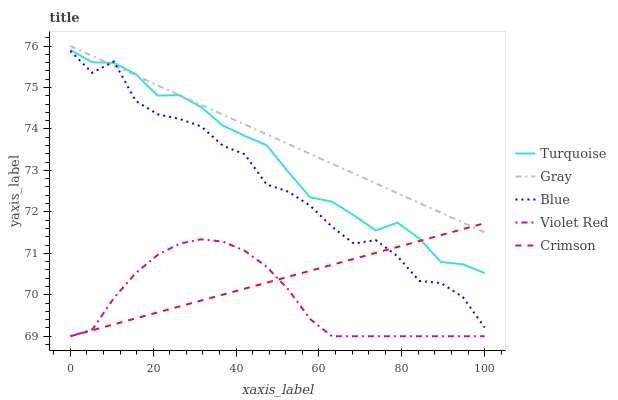Does Turquoise have the minimum area under the curve?
Answer yes or no. No. Does Turquoise have the maximum area under the curve?
Answer yes or no. No. Is Gray the smoothest?
Answer yes or no. No. Is Gray the roughest?
Answer yes or no. No. Does Turquoise have the lowest value?
Answer yes or no. No. Does Turquoise have the highest value?
Answer yes or no. No. Is Violet Red less than Blue?
Answer yes or no. Yes. Is Turquoise greater than Violet Red?
Answer yes or no. Yes. Does Violet Red intersect Blue?
Answer yes or no. No. 